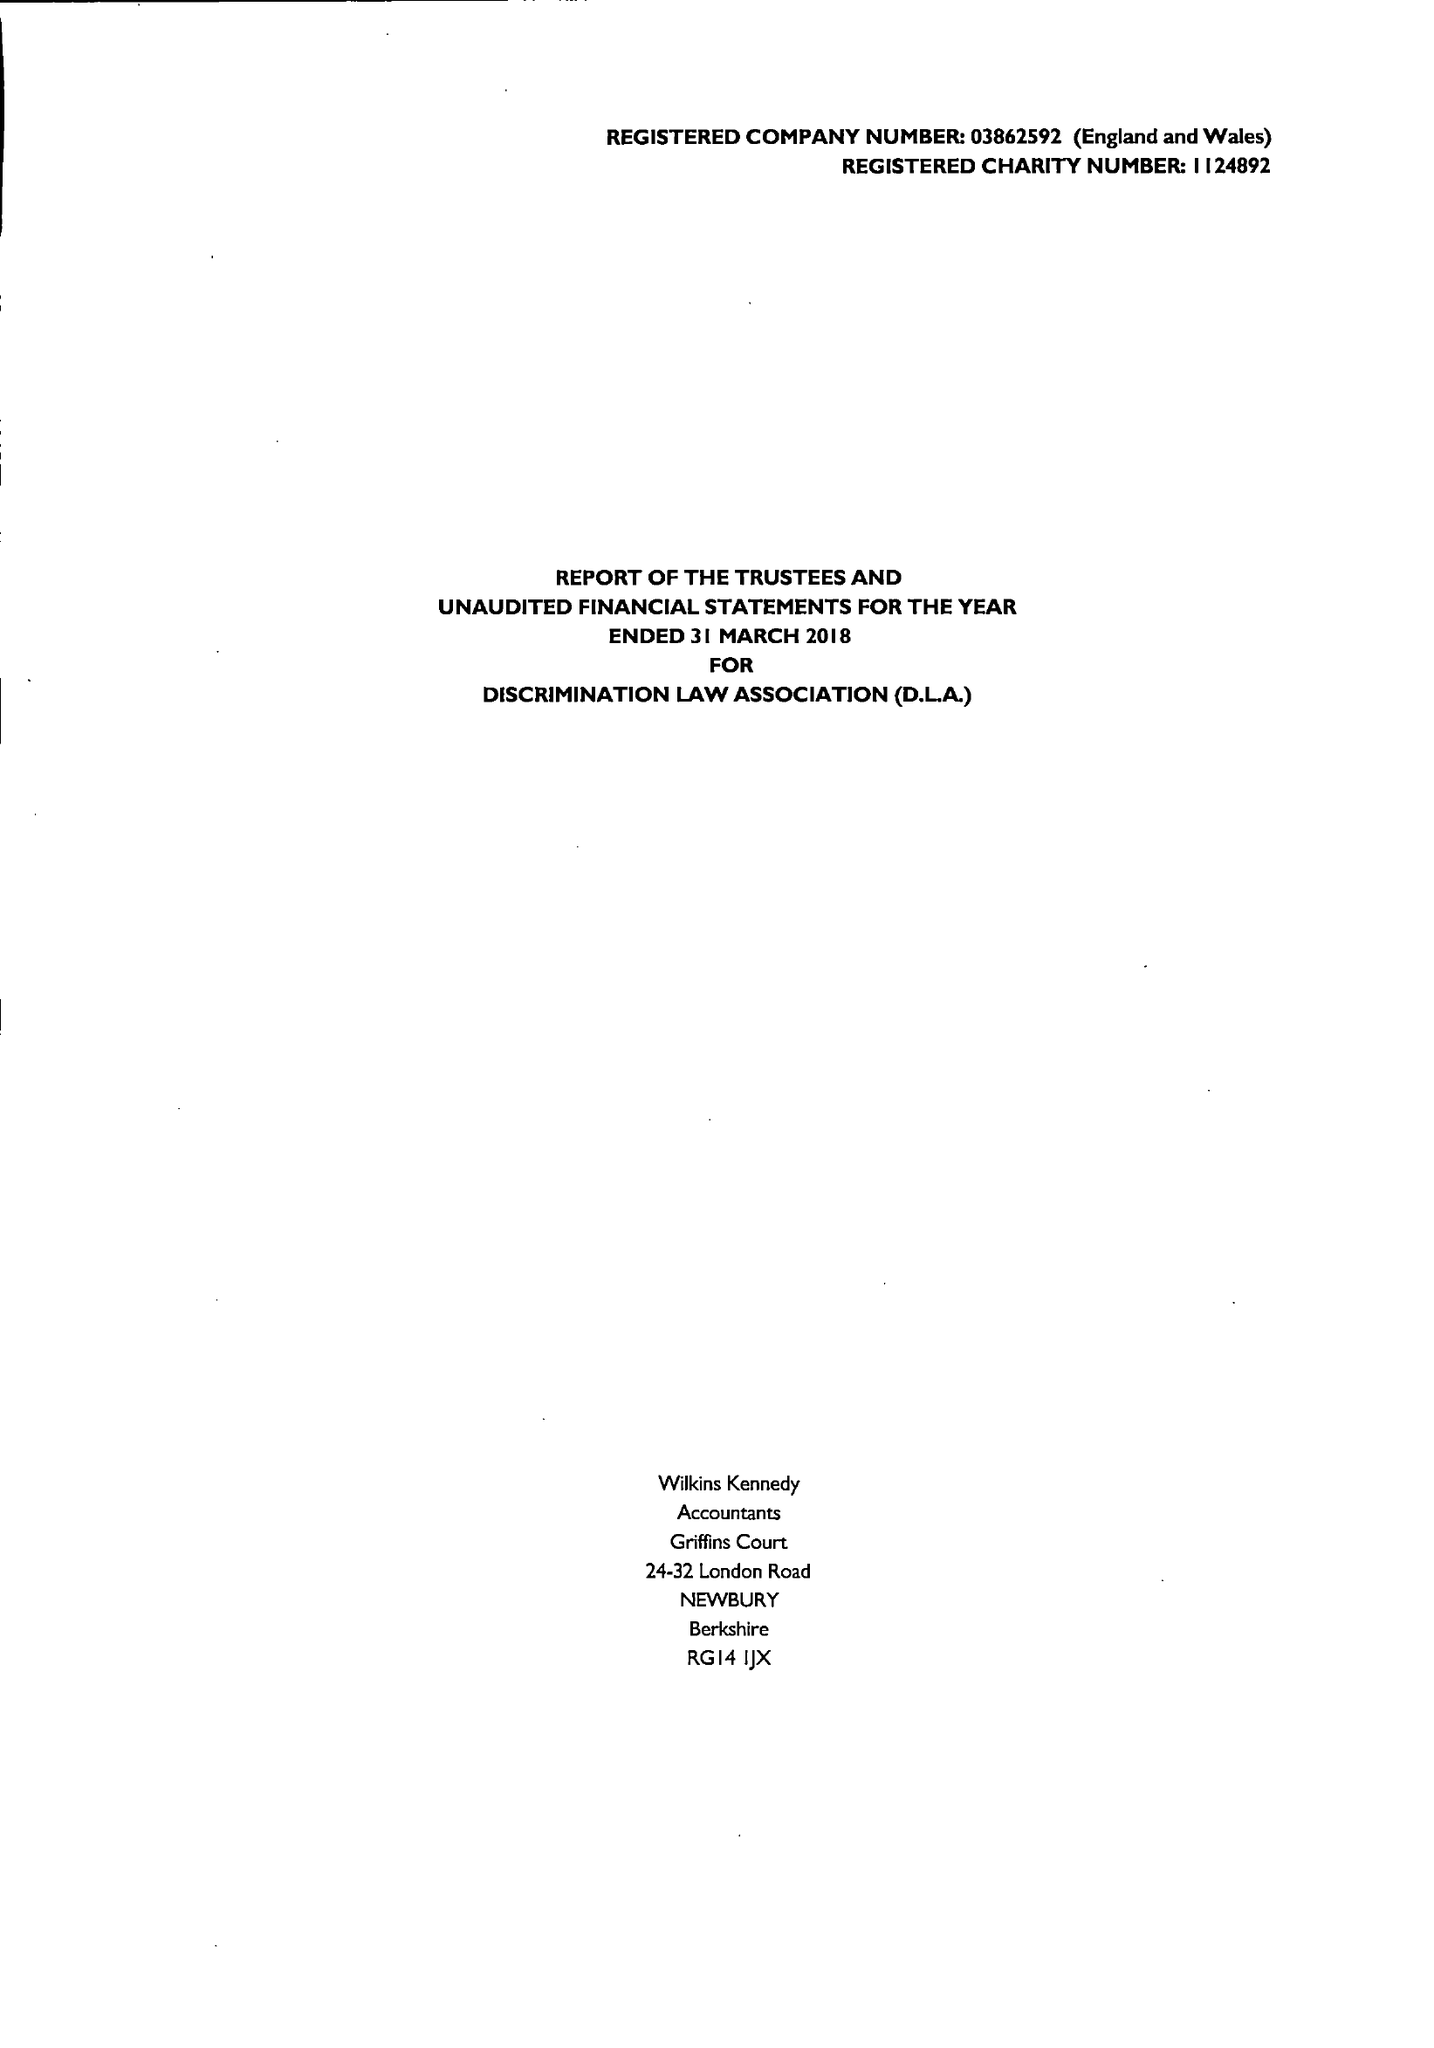What is the value for the income_annually_in_british_pounds?
Answer the question using a single word or phrase. 26791.00 